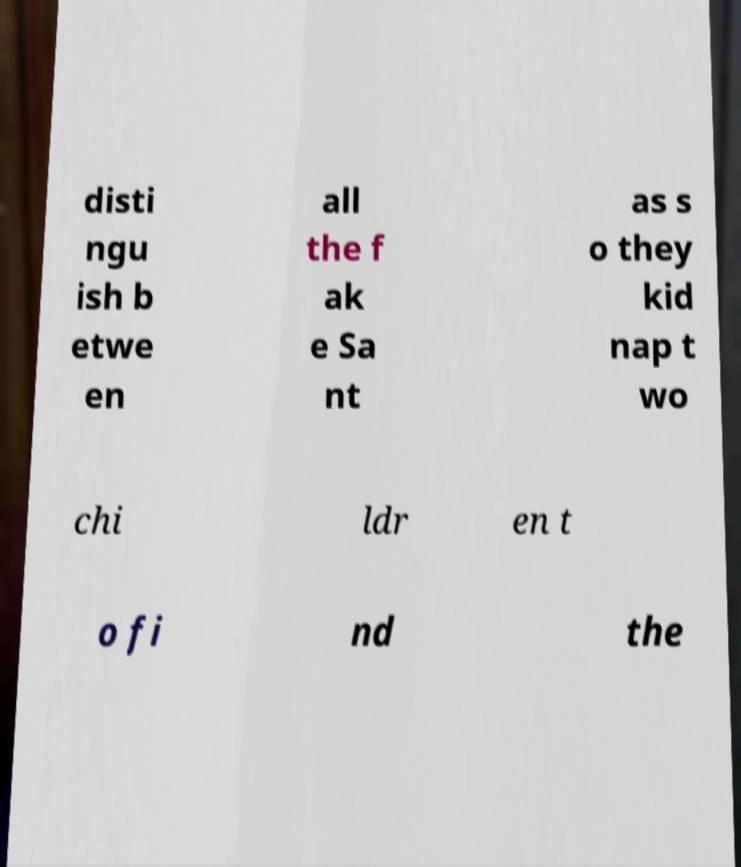Could you extract and type out the text from this image? disti ngu ish b etwe en all the f ak e Sa nt as s o they kid nap t wo chi ldr en t o fi nd the 